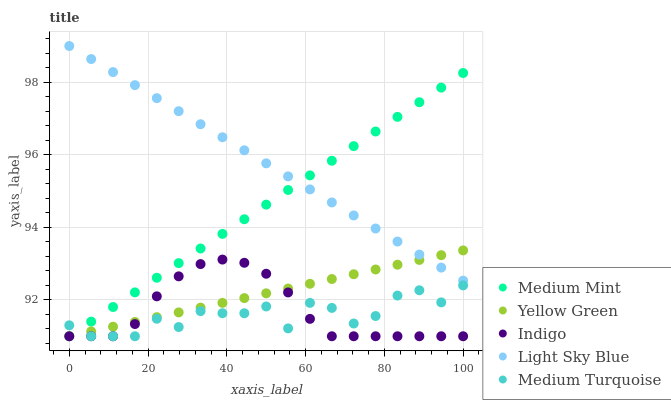Does Medium Turquoise have the minimum area under the curve?
Answer yes or no. Yes. Does Light Sky Blue have the maximum area under the curve?
Answer yes or no. Yes. Does Indigo have the minimum area under the curve?
Answer yes or no. No. Does Indigo have the maximum area under the curve?
Answer yes or no. No. Is Medium Mint the smoothest?
Answer yes or no. Yes. Is Medium Turquoise the roughest?
Answer yes or no. Yes. Is Light Sky Blue the smoothest?
Answer yes or no. No. Is Light Sky Blue the roughest?
Answer yes or no. No. Does Medium Mint have the lowest value?
Answer yes or no. Yes. Does Light Sky Blue have the lowest value?
Answer yes or no. No. Does Light Sky Blue have the highest value?
Answer yes or no. Yes. Does Indigo have the highest value?
Answer yes or no. No. Is Indigo less than Light Sky Blue?
Answer yes or no. Yes. Is Light Sky Blue greater than Indigo?
Answer yes or no. Yes. Does Medium Turquoise intersect Indigo?
Answer yes or no. Yes. Is Medium Turquoise less than Indigo?
Answer yes or no. No. Is Medium Turquoise greater than Indigo?
Answer yes or no. No. Does Indigo intersect Light Sky Blue?
Answer yes or no. No. 